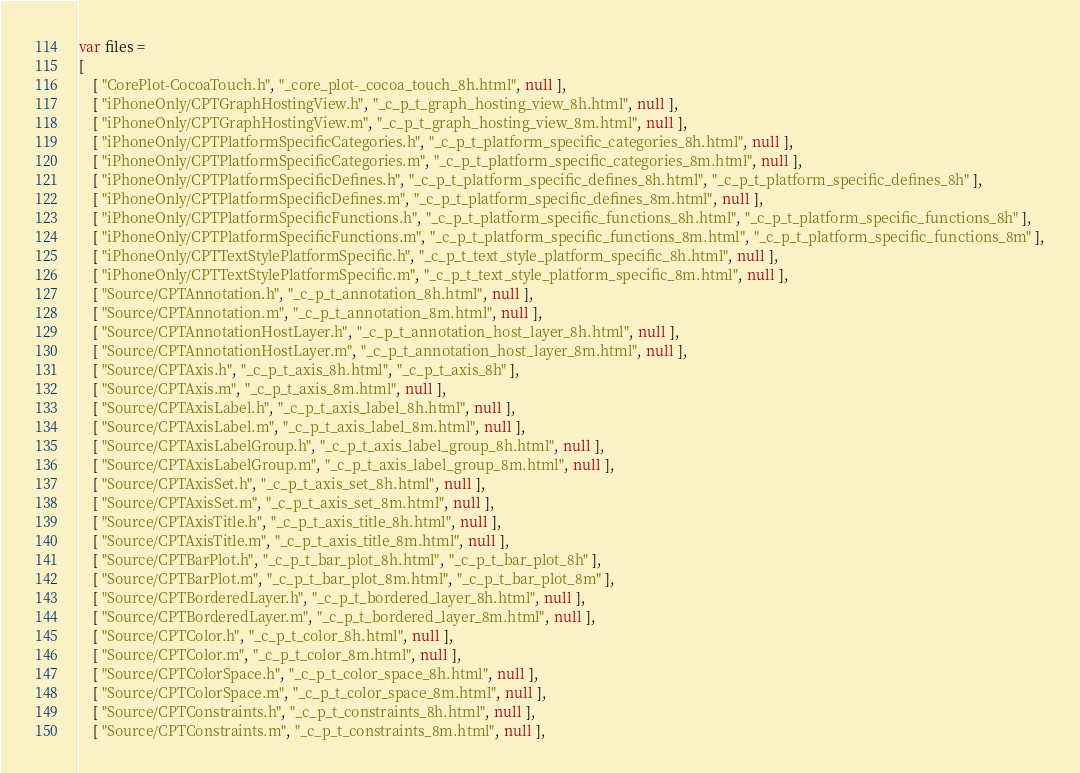Convert code to text. <code><loc_0><loc_0><loc_500><loc_500><_JavaScript_>var files =
[
    [ "CorePlot-CocoaTouch.h", "_core_plot-_cocoa_touch_8h.html", null ],
    [ "iPhoneOnly/CPTGraphHostingView.h", "_c_p_t_graph_hosting_view_8h.html", null ],
    [ "iPhoneOnly/CPTGraphHostingView.m", "_c_p_t_graph_hosting_view_8m.html", null ],
    [ "iPhoneOnly/CPTPlatformSpecificCategories.h", "_c_p_t_platform_specific_categories_8h.html", null ],
    [ "iPhoneOnly/CPTPlatformSpecificCategories.m", "_c_p_t_platform_specific_categories_8m.html", null ],
    [ "iPhoneOnly/CPTPlatformSpecificDefines.h", "_c_p_t_platform_specific_defines_8h.html", "_c_p_t_platform_specific_defines_8h" ],
    [ "iPhoneOnly/CPTPlatformSpecificDefines.m", "_c_p_t_platform_specific_defines_8m.html", null ],
    [ "iPhoneOnly/CPTPlatformSpecificFunctions.h", "_c_p_t_platform_specific_functions_8h.html", "_c_p_t_platform_specific_functions_8h" ],
    [ "iPhoneOnly/CPTPlatformSpecificFunctions.m", "_c_p_t_platform_specific_functions_8m.html", "_c_p_t_platform_specific_functions_8m" ],
    [ "iPhoneOnly/CPTTextStylePlatformSpecific.h", "_c_p_t_text_style_platform_specific_8h.html", null ],
    [ "iPhoneOnly/CPTTextStylePlatformSpecific.m", "_c_p_t_text_style_platform_specific_8m.html", null ],
    [ "Source/CPTAnnotation.h", "_c_p_t_annotation_8h.html", null ],
    [ "Source/CPTAnnotation.m", "_c_p_t_annotation_8m.html", null ],
    [ "Source/CPTAnnotationHostLayer.h", "_c_p_t_annotation_host_layer_8h.html", null ],
    [ "Source/CPTAnnotationHostLayer.m", "_c_p_t_annotation_host_layer_8m.html", null ],
    [ "Source/CPTAxis.h", "_c_p_t_axis_8h.html", "_c_p_t_axis_8h" ],
    [ "Source/CPTAxis.m", "_c_p_t_axis_8m.html", null ],
    [ "Source/CPTAxisLabel.h", "_c_p_t_axis_label_8h.html", null ],
    [ "Source/CPTAxisLabel.m", "_c_p_t_axis_label_8m.html", null ],
    [ "Source/CPTAxisLabelGroup.h", "_c_p_t_axis_label_group_8h.html", null ],
    [ "Source/CPTAxisLabelGroup.m", "_c_p_t_axis_label_group_8m.html", null ],
    [ "Source/CPTAxisSet.h", "_c_p_t_axis_set_8h.html", null ],
    [ "Source/CPTAxisSet.m", "_c_p_t_axis_set_8m.html", null ],
    [ "Source/CPTAxisTitle.h", "_c_p_t_axis_title_8h.html", null ],
    [ "Source/CPTAxisTitle.m", "_c_p_t_axis_title_8m.html", null ],
    [ "Source/CPTBarPlot.h", "_c_p_t_bar_plot_8h.html", "_c_p_t_bar_plot_8h" ],
    [ "Source/CPTBarPlot.m", "_c_p_t_bar_plot_8m.html", "_c_p_t_bar_plot_8m" ],
    [ "Source/CPTBorderedLayer.h", "_c_p_t_bordered_layer_8h.html", null ],
    [ "Source/CPTBorderedLayer.m", "_c_p_t_bordered_layer_8m.html", null ],
    [ "Source/CPTColor.h", "_c_p_t_color_8h.html", null ],
    [ "Source/CPTColor.m", "_c_p_t_color_8m.html", null ],
    [ "Source/CPTColorSpace.h", "_c_p_t_color_space_8h.html", null ],
    [ "Source/CPTColorSpace.m", "_c_p_t_color_space_8m.html", null ],
    [ "Source/CPTConstraints.h", "_c_p_t_constraints_8h.html", null ],
    [ "Source/CPTConstraints.m", "_c_p_t_constraints_8m.html", null ],</code> 